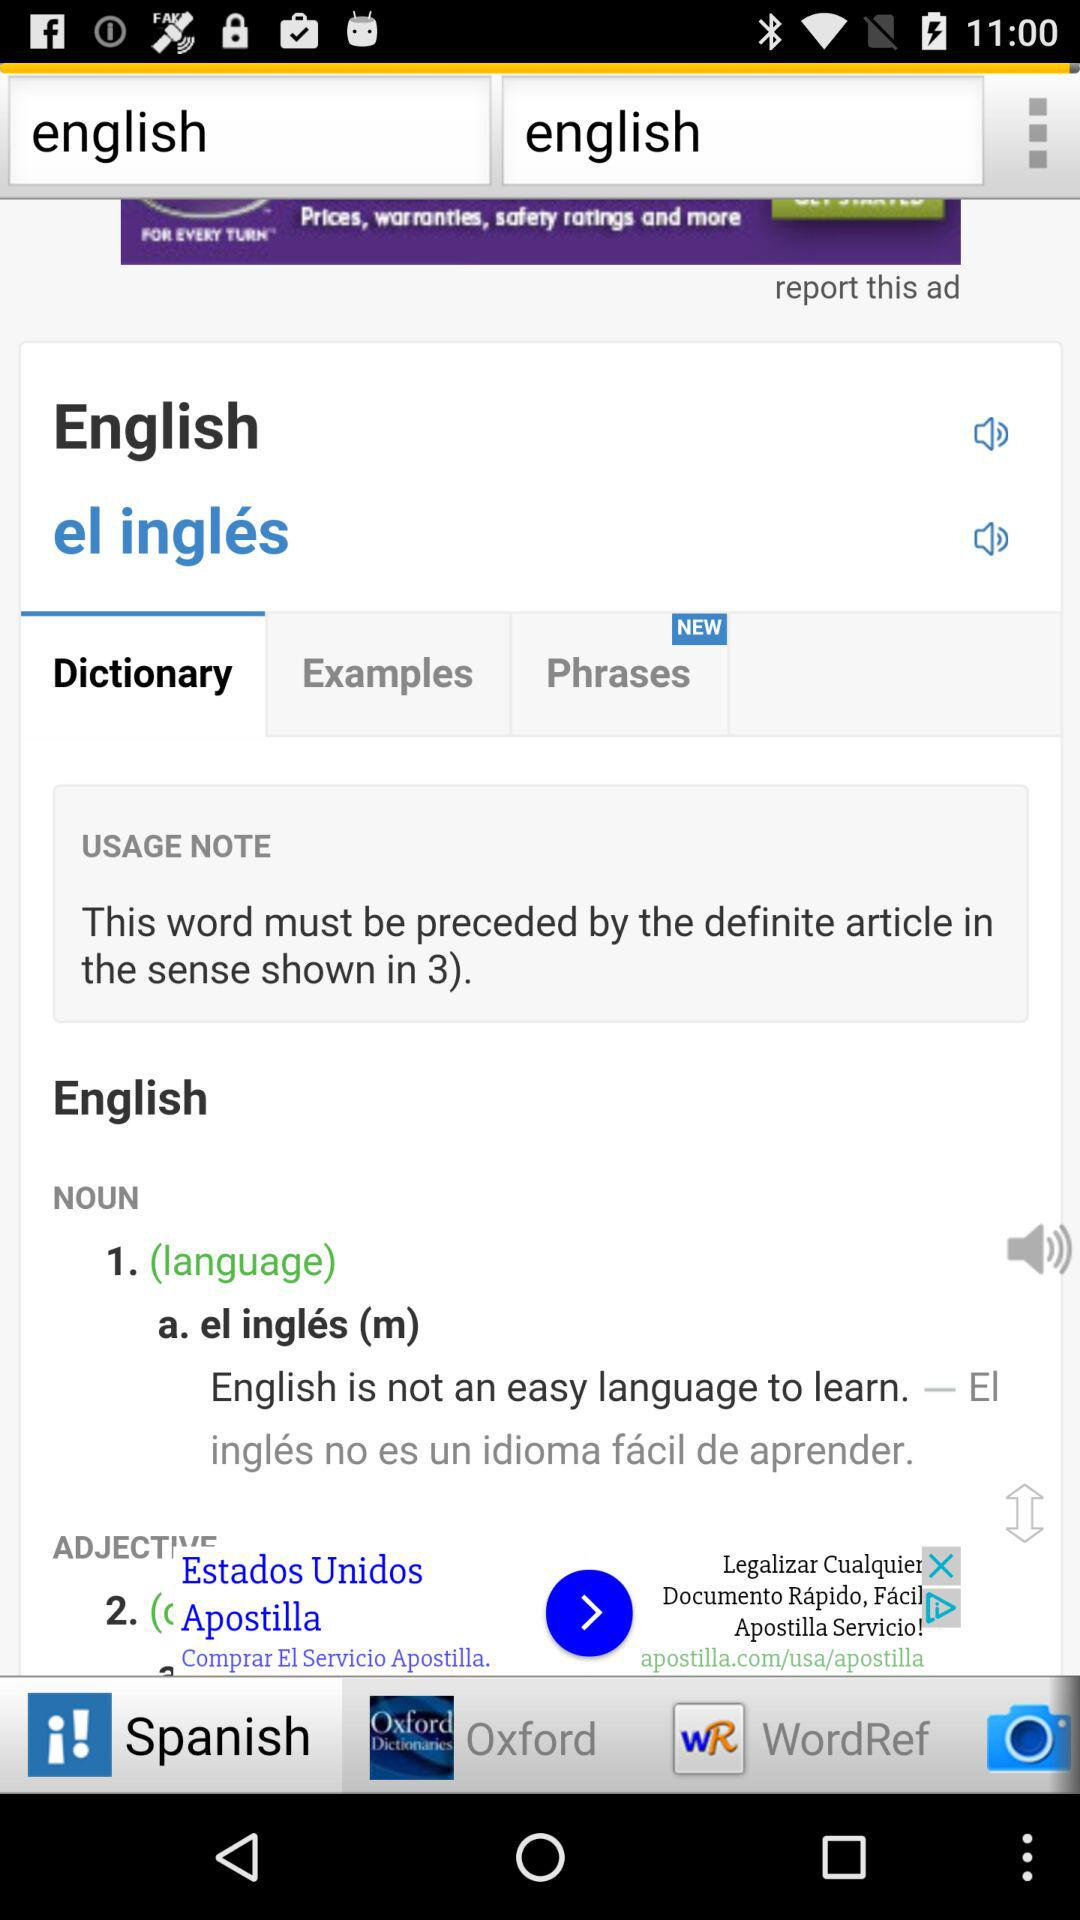Which tab is selected? The selected tabs are "Dictionary" and "Spanish". 